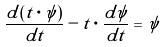<formula> <loc_0><loc_0><loc_500><loc_500>\frac { d ( t \cdot \psi ) } { d t } - t \cdot \frac { d \psi } { d t } = \psi</formula> 